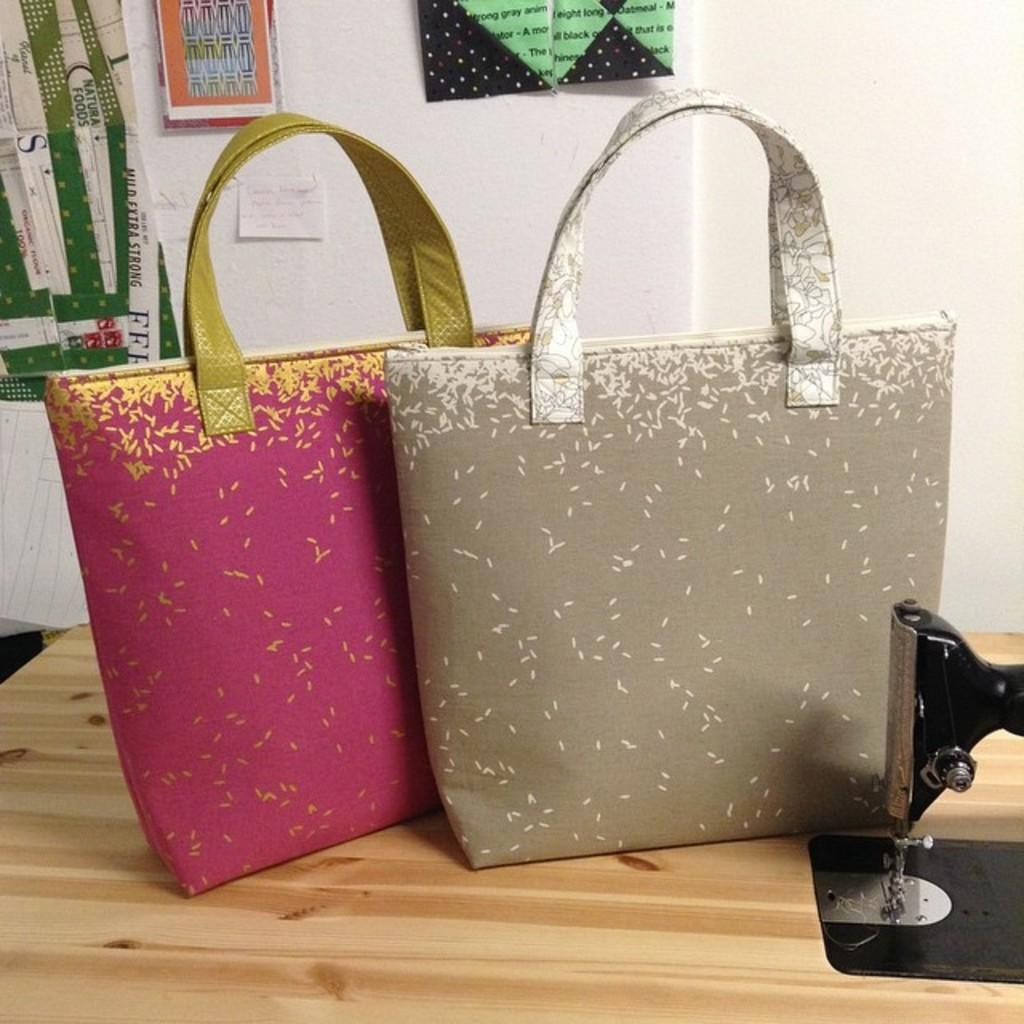What objects are on the table in the image? There are two bags on the table. What can be seen in the background of the image? There is a wall in the image. What is on the wall in the image? There are posters on the wall. What flavor of pancake is being served in the image? There is no pancake present in the image, so it is not possible to determine the flavor. 